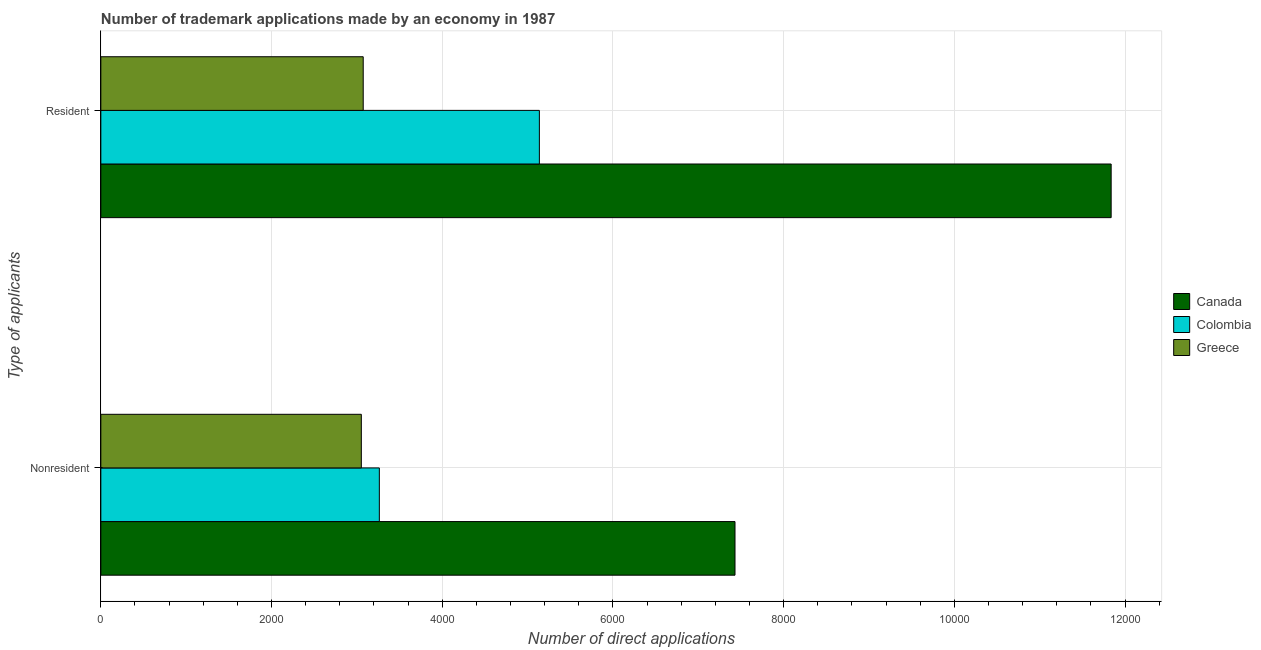Are the number of bars per tick equal to the number of legend labels?
Ensure brevity in your answer.  Yes. How many bars are there on the 2nd tick from the top?
Make the answer very short. 3. How many bars are there on the 1st tick from the bottom?
Your response must be concise. 3. What is the label of the 2nd group of bars from the top?
Provide a short and direct response. Nonresident. What is the number of trademark applications made by residents in Canada?
Make the answer very short. 1.18e+04. Across all countries, what is the maximum number of trademark applications made by non residents?
Provide a succinct answer. 7430. Across all countries, what is the minimum number of trademark applications made by residents?
Offer a terse response. 3074. In which country was the number of trademark applications made by non residents minimum?
Provide a succinct answer. Greece. What is the total number of trademark applications made by residents in the graph?
Give a very brief answer. 2.00e+04. What is the difference between the number of trademark applications made by non residents in Colombia and that in Canada?
Give a very brief answer. -4167. What is the difference between the number of trademark applications made by non residents in Colombia and the number of trademark applications made by residents in Greece?
Make the answer very short. 189. What is the average number of trademark applications made by non residents per country?
Provide a short and direct response. 4581.67. What is the difference between the number of trademark applications made by residents and number of trademark applications made by non residents in Colombia?
Your response must be concise. 1875. What is the ratio of the number of trademark applications made by non residents in Canada to that in Colombia?
Offer a very short reply. 2.28. In how many countries, is the number of trademark applications made by non residents greater than the average number of trademark applications made by non residents taken over all countries?
Provide a succinct answer. 1. What does the 2nd bar from the top in Resident represents?
Give a very brief answer. Colombia. How many bars are there?
Make the answer very short. 6. What is the difference between two consecutive major ticks on the X-axis?
Offer a very short reply. 2000. Does the graph contain any zero values?
Your answer should be very brief. No. Does the graph contain grids?
Ensure brevity in your answer.  Yes. Where does the legend appear in the graph?
Your response must be concise. Center right. How many legend labels are there?
Your answer should be compact. 3. How are the legend labels stacked?
Make the answer very short. Vertical. What is the title of the graph?
Offer a very short reply. Number of trademark applications made by an economy in 1987. Does "Myanmar" appear as one of the legend labels in the graph?
Offer a very short reply. No. What is the label or title of the X-axis?
Make the answer very short. Number of direct applications. What is the label or title of the Y-axis?
Keep it short and to the point. Type of applicants. What is the Number of direct applications of Canada in Nonresident?
Keep it short and to the point. 7430. What is the Number of direct applications in Colombia in Nonresident?
Provide a succinct answer. 3263. What is the Number of direct applications in Greece in Nonresident?
Your answer should be very brief. 3052. What is the Number of direct applications in Canada in Resident?
Provide a short and direct response. 1.18e+04. What is the Number of direct applications in Colombia in Resident?
Make the answer very short. 5138. What is the Number of direct applications in Greece in Resident?
Offer a terse response. 3074. Across all Type of applicants, what is the maximum Number of direct applications of Canada?
Provide a succinct answer. 1.18e+04. Across all Type of applicants, what is the maximum Number of direct applications of Colombia?
Ensure brevity in your answer.  5138. Across all Type of applicants, what is the maximum Number of direct applications of Greece?
Your answer should be very brief. 3074. Across all Type of applicants, what is the minimum Number of direct applications in Canada?
Provide a short and direct response. 7430. Across all Type of applicants, what is the minimum Number of direct applications of Colombia?
Ensure brevity in your answer.  3263. Across all Type of applicants, what is the minimum Number of direct applications of Greece?
Keep it short and to the point. 3052. What is the total Number of direct applications of Canada in the graph?
Keep it short and to the point. 1.93e+04. What is the total Number of direct applications in Colombia in the graph?
Offer a very short reply. 8401. What is the total Number of direct applications of Greece in the graph?
Make the answer very short. 6126. What is the difference between the Number of direct applications of Canada in Nonresident and that in Resident?
Keep it short and to the point. -4407. What is the difference between the Number of direct applications of Colombia in Nonresident and that in Resident?
Keep it short and to the point. -1875. What is the difference between the Number of direct applications of Greece in Nonresident and that in Resident?
Your answer should be compact. -22. What is the difference between the Number of direct applications of Canada in Nonresident and the Number of direct applications of Colombia in Resident?
Give a very brief answer. 2292. What is the difference between the Number of direct applications of Canada in Nonresident and the Number of direct applications of Greece in Resident?
Offer a terse response. 4356. What is the difference between the Number of direct applications of Colombia in Nonresident and the Number of direct applications of Greece in Resident?
Provide a succinct answer. 189. What is the average Number of direct applications of Canada per Type of applicants?
Give a very brief answer. 9633.5. What is the average Number of direct applications of Colombia per Type of applicants?
Your answer should be very brief. 4200.5. What is the average Number of direct applications in Greece per Type of applicants?
Provide a short and direct response. 3063. What is the difference between the Number of direct applications of Canada and Number of direct applications of Colombia in Nonresident?
Your response must be concise. 4167. What is the difference between the Number of direct applications in Canada and Number of direct applications in Greece in Nonresident?
Provide a succinct answer. 4378. What is the difference between the Number of direct applications in Colombia and Number of direct applications in Greece in Nonresident?
Make the answer very short. 211. What is the difference between the Number of direct applications of Canada and Number of direct applications of Colombia in Resident?
Ensure brevity in your answer.  6699. What is the difference between the Number of direct applications of Canada and Number of direct applications of Greece in Resident?
Offer a very short reply. 8763. What is the difference between the Number of direct applications of Colombia and Number of direct applications of Greece in Resident?
Keep it short and to the point. 2064. What is the ratio of the Number of direct applications of Canada in Nonresident to that in Resident?
Provide a succinct answer. 0.63. What is the ratio of the Number of direct applications of Colombia in Nonresident to that in Resident?
Make the answer very short. 0.64. What is the difference between the highest and the second highest Number of direct applications in Canada?
Provide a succinct answer. 4407. What is the difference between the highest and the second highest Number of direct applications of Colombia?
Keep it short and to the point. 1875. What is the difference between the highest and the lowest Number of direct applications in Canada?
Provide a short and direct response. 4407. What is the difference between the highest and the lowest Number of direct applications of Colombia?
Provide a succinct answer. 1875. What is the difference between the highest and the lowest Number of direct applications in Greece?
Your response must be concise. 22. 